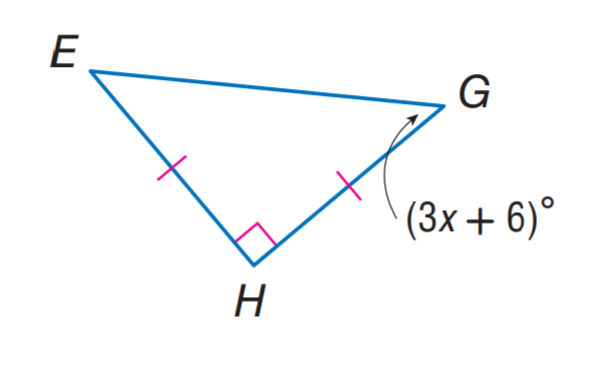Answer the mathemtical geometry problem and directly provide the correct option letter.
Question: Find x.
Choices: A: 3 B: 6 C: 13 D: 19 C 